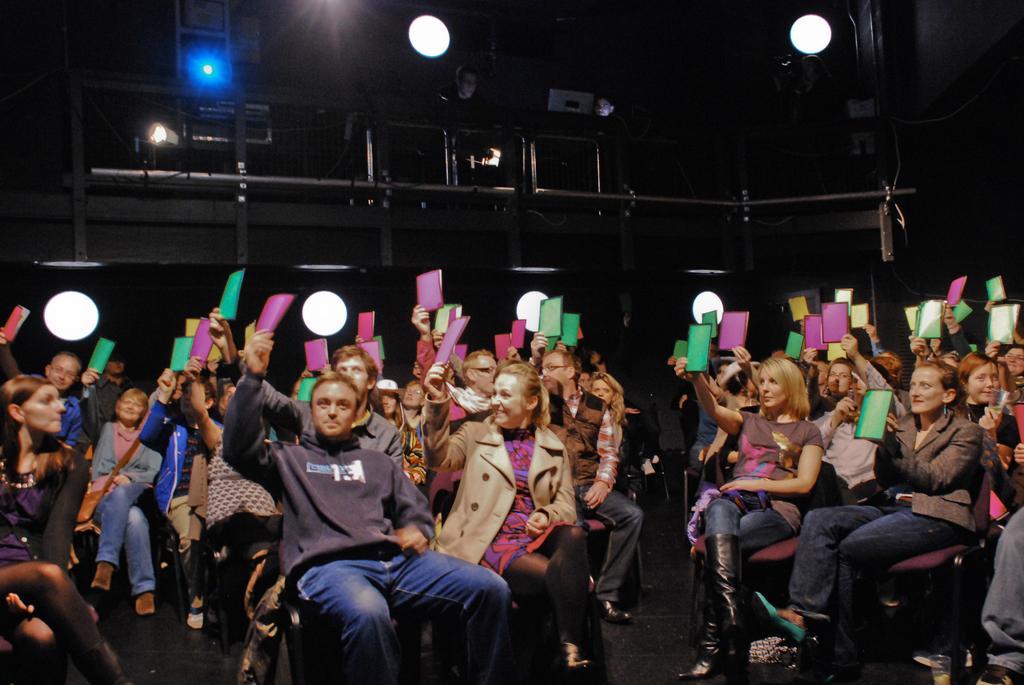Can you describe this image briefly? This picture describes about group of people, they are seated on the chairs, and they are holding an objects, in the background we can see few lights. 